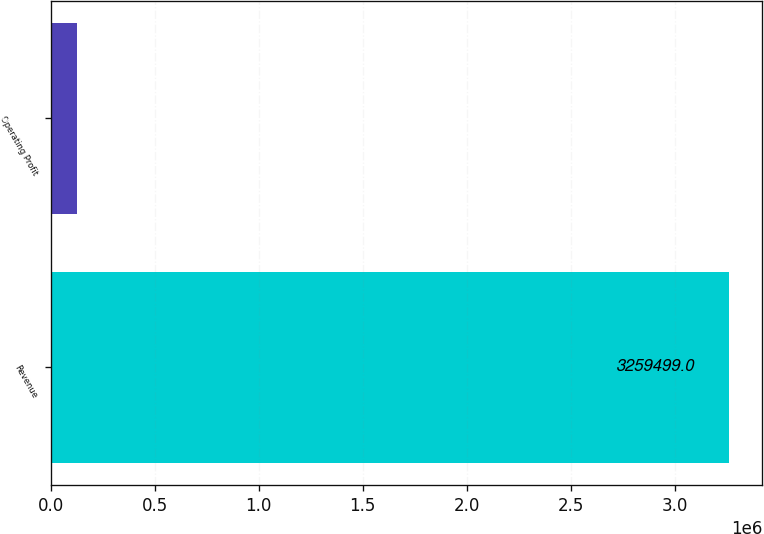Convert chart. <chart><loc_0><loc_0><loc_500><loc_500><bar_chart><fcel>Revenue<fcel>Operating Profit<nl><fcel>3.2595e+06<fcel>126604<nl></chart> 